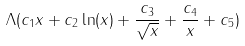<formula> <loc_0><loc_0><loc_500><loc_500>\Lambda ( c _ { 1 } x + c _ { 2 } \ln ( x ) + \frac { c _ { 3 } } { \sqrt { x } } + \frac { c _ { 4 } } { x } + c _ { 5 } )</formula> 